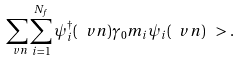Convert formula to latex. <formula><loc_0><loc_0><loc_500><loc_500>\sum _ { \ v n } \sum _ { i = 1 } ^ { N _ { f } } \psi _ { i } ^ { \dag } ( \ v n ) \gamma _ { 0 } m _ { i } \psi _ { i } ( \ v n ) \ > .</formula> 